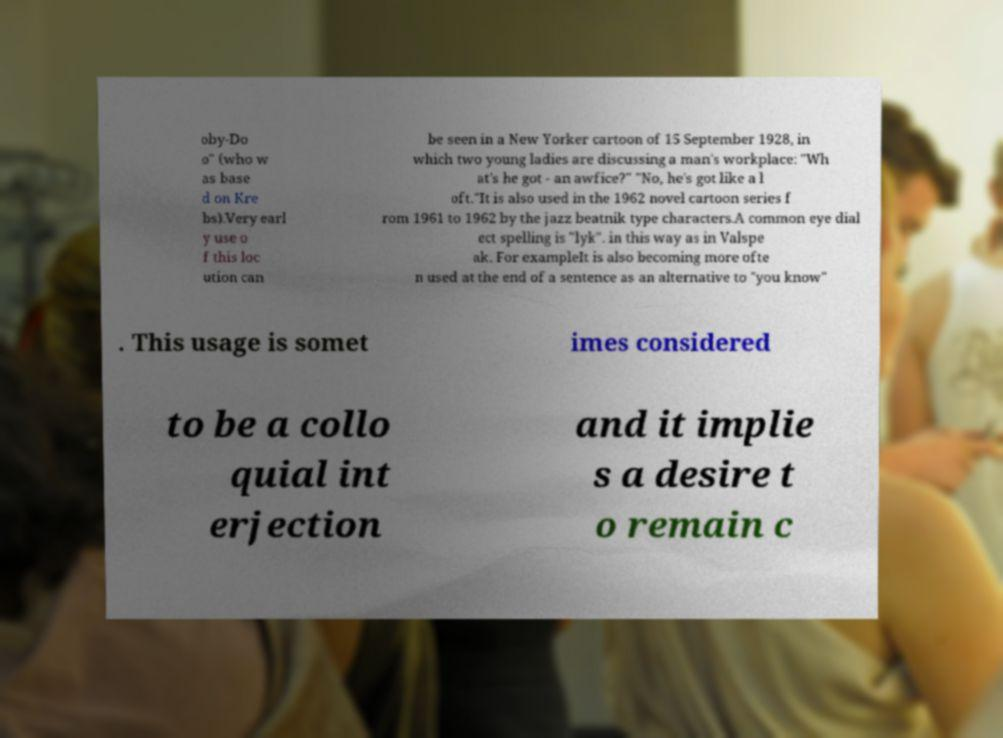I need the written content from this picture converted into text. Can you do that? oby-Do o" (who w as base d on Kre bs).Very earl y use o f this loc ution can be seen in a New Yorker cartoon of 15 September 1928, in which two young ladies are discussing a man's workplace: "Wh at's he got - an awfice?" "No, he's got like a l oft."It is also used in the 1962 novel cartoon series f rom 1961 to 1962 by the jazz beatnik type characters.A common eye dial ect spelling is "lyk". in this way as in Valspe ak. For exampleIt is also becoming more ofte n used at the end of a sentence as an alternative to "you know" . This usage is somet imes considered to be a collo quial int erjection and it implie s a desire t o remain c 